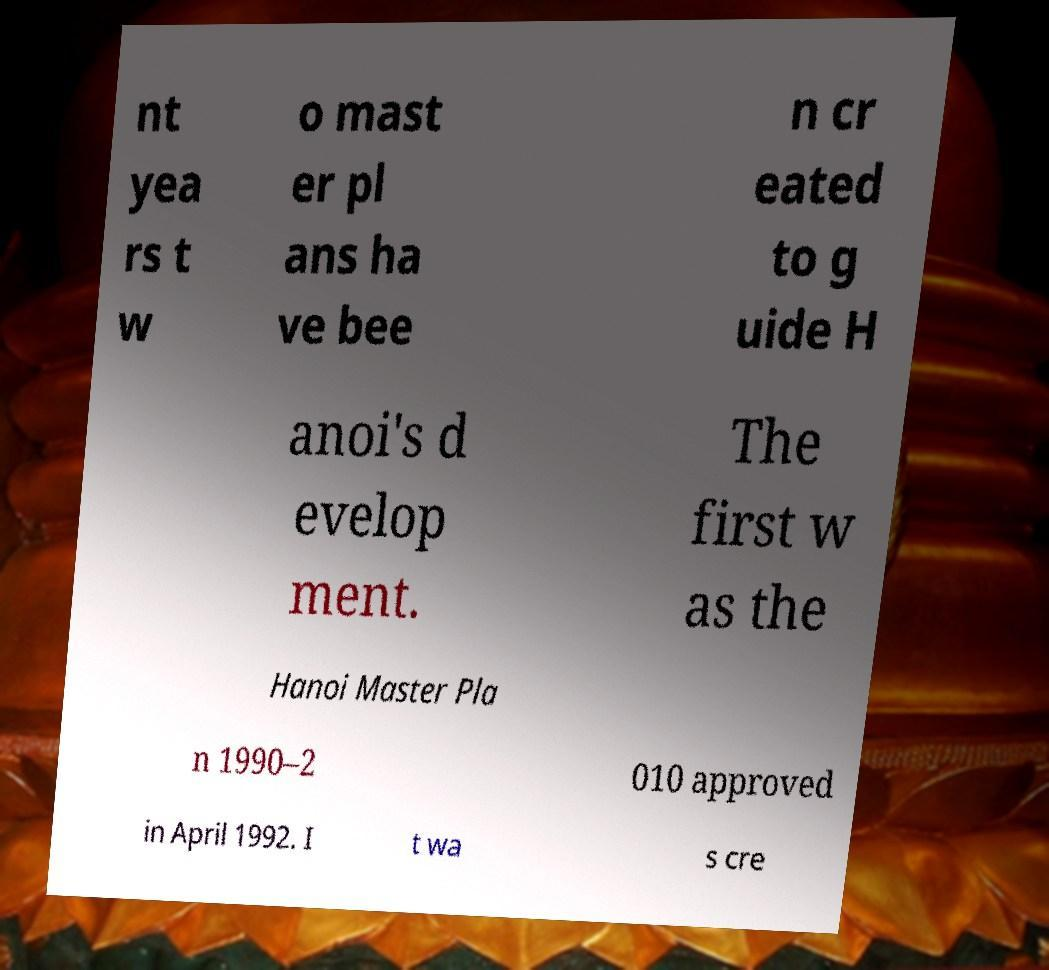For documentation purposes, I need the text within this image transcribed. Could you provide that? nt yea rs t w o mast er pl ans ha ve bee n cr eated to g uide H anoi's d evelop ment. The first w as the Hanoi Master Pla n 1990–2 010 approved in April 1992. I t wa s cre 